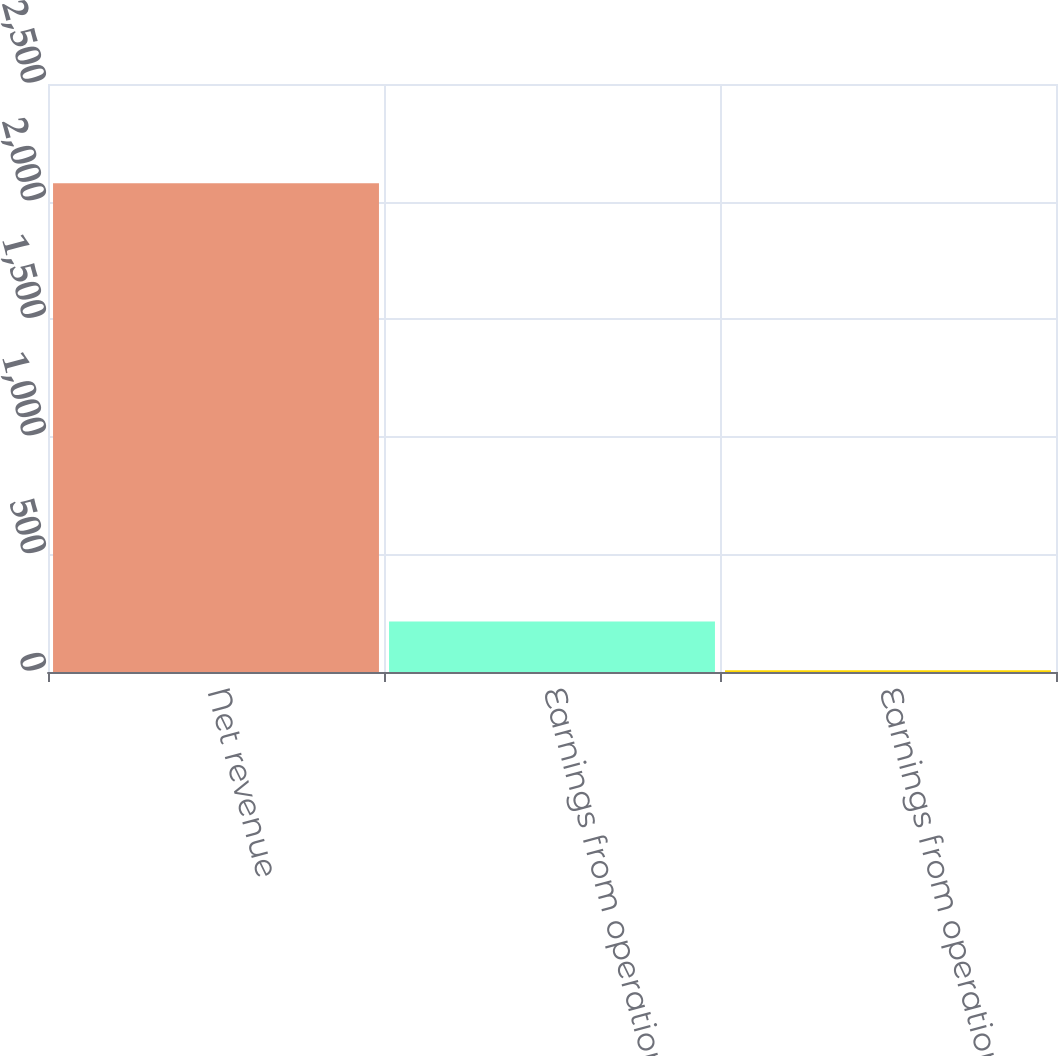<chart> <loc_0><loc_0><loc_500><loc_500><bar_chart><fcel>Net revenue<fcel>Earnings from operations<fcel>Earnings from operations as a<nl><fcel>2078<fcel>214.19<fcel>7.1<nl></chart> 